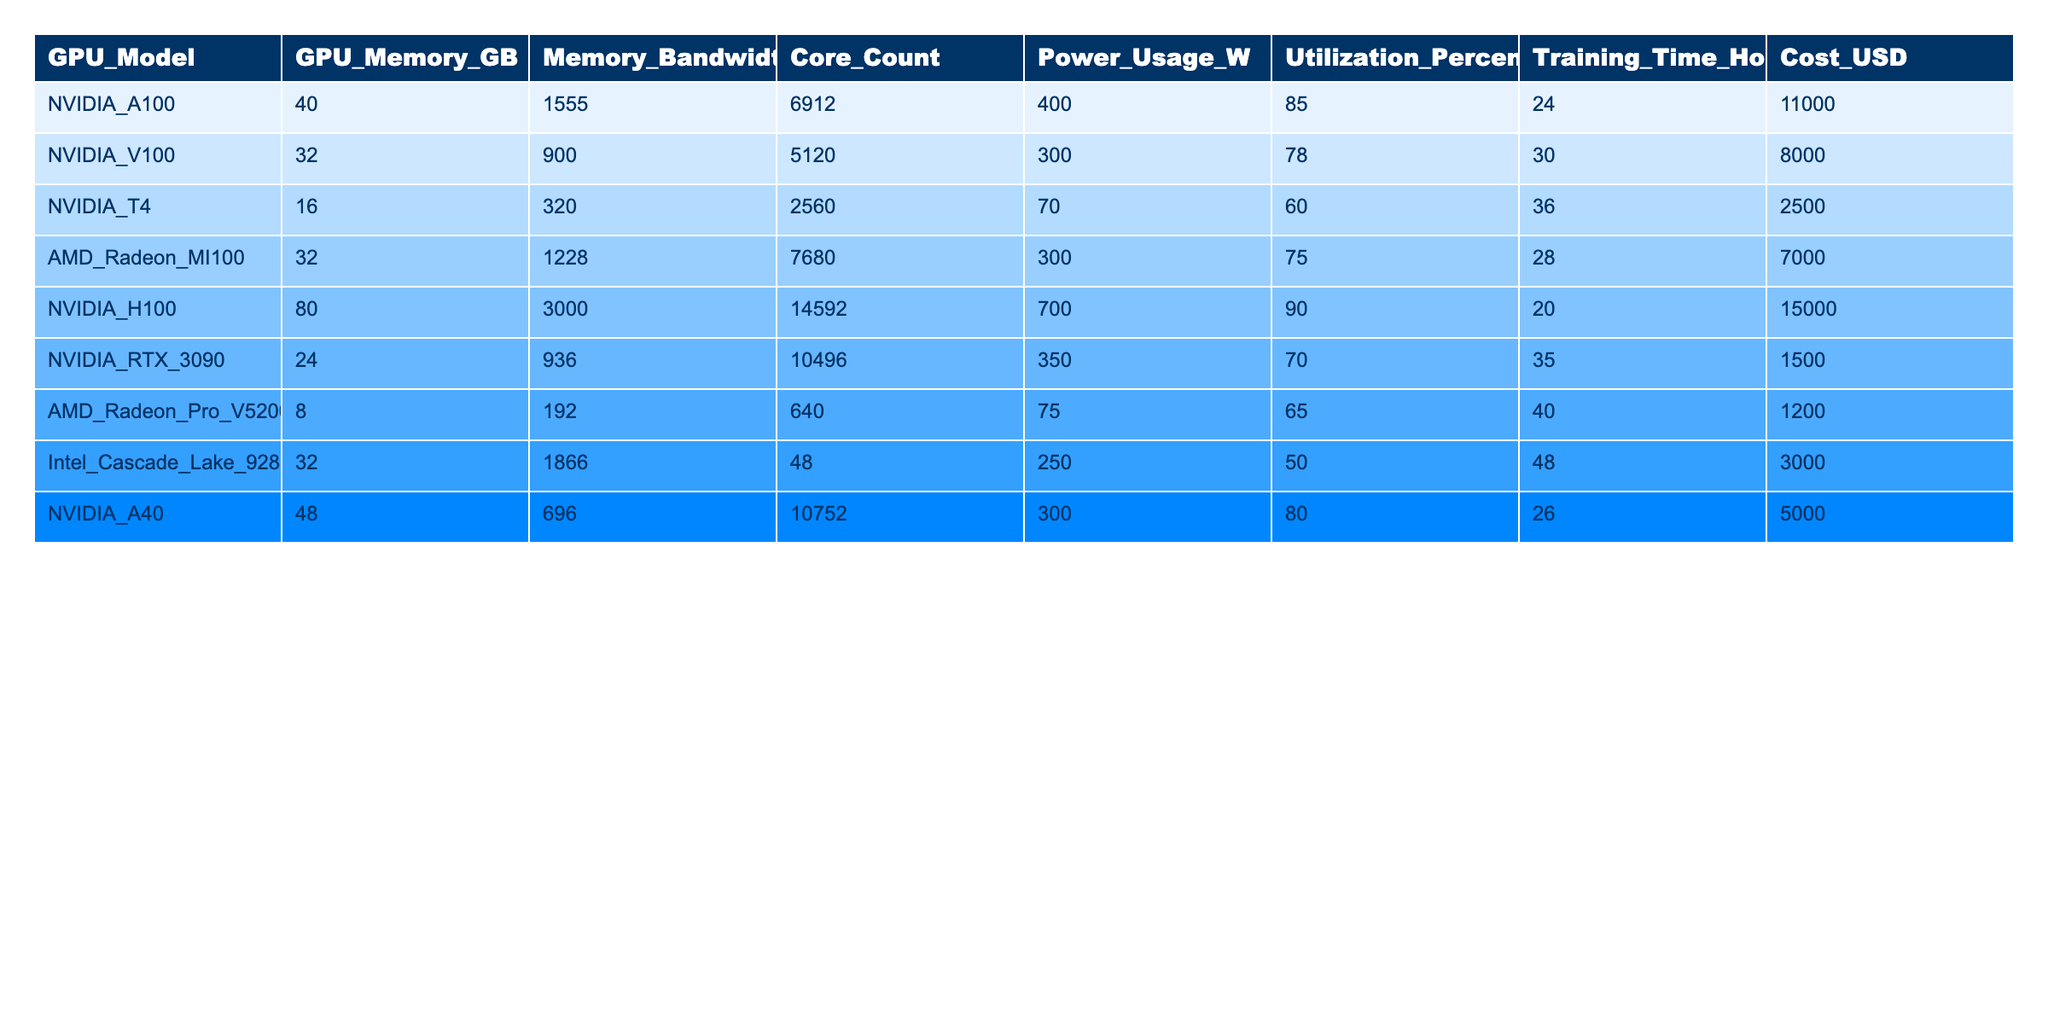What is the GPU model with the highest memory? By examining the "GPU_Model" and "GPU_Memory_GB" columns, the NVIDIA_H100 has 80 GB of memory, which is greater than all other models listed.
Answer: NVIDIA_H100 Which GPU has the lowest utilization percentage? Looking at the "Utilization_Percentage" column, the Intel_Cascade_Lake_9282 has the lowest value of 50%.
Answer: Intel_Cascade_Lake_9282 What is the total cost of all the GPUs listed? Summing the "Cost_USD" values gives 11000 + 8000 + 2500 + 7000 + 15000 + 1500 + 1200 + 3000 + 5000 =  42300.
Answer: 42300 Which GPU has the highest power usage? The "Power_Usage_W" column shows that the NVIDIA_H100 has the highest power usage at 700 W.
Answer: NVIDIA_H100 Is the NVIDIA_A100 more power-efficient than the NVIDIA_V100 concerning power usage per GHz of memory bandwidth (divide power usage by memory bandwidth)? The NVIDIA_A100 has 400 W / 1555 GB/s = 0.257 W/GB/s, while the NVIDIA_V100 has 300 W / 900 GB/s = 0.333 W/GB/s. The A100 is more power-efficient.
Answer: Yes What is the average training time of all the GPUs? The training times are 24, 30, 36, 28, 20, 35, 40, 48, 26. The average is (24 + 30 + 36 + 28 + 20 + 35 + 40 + 48 + 26) / 9 = 30.
Answer: 30 If I wanted to sort by power usage, which GPU would be ranked second? Sorting the "Power_Usage_W" column in descending order, the values are 700, 400, 300, 300, 250, and so on, so the second-highest power usage is 400 W from the NVIDIA_A100.
Answer: NVIDIA_A100 What is the median GPU memory size from the list? The memory sizes are 40, 32, 16, 32, 80, 24, 8, 32, 48. Sorting these gives 8, 16, 24, 32, 32, 32, 40, 48, 80. The median is the 5th value which is 32.
Answer: 32 Which GPU has the best ratio of training time hours to cost? Calculating the ratio for each (Training_Time_Hours / Cost_USD), the NVIDIA_T4 has a ratio of 36/2500 = 0.0144, which is better than others.
Answer: NVIDIA_T4 Does any GPU have both a high utilization percentage (above 80%) and low training time (less than 25 hours)? Checking both criteria, the NVIDIA_H100 meets the utilization of 90% and has a training time of 20 hours.
Answer: Yes 